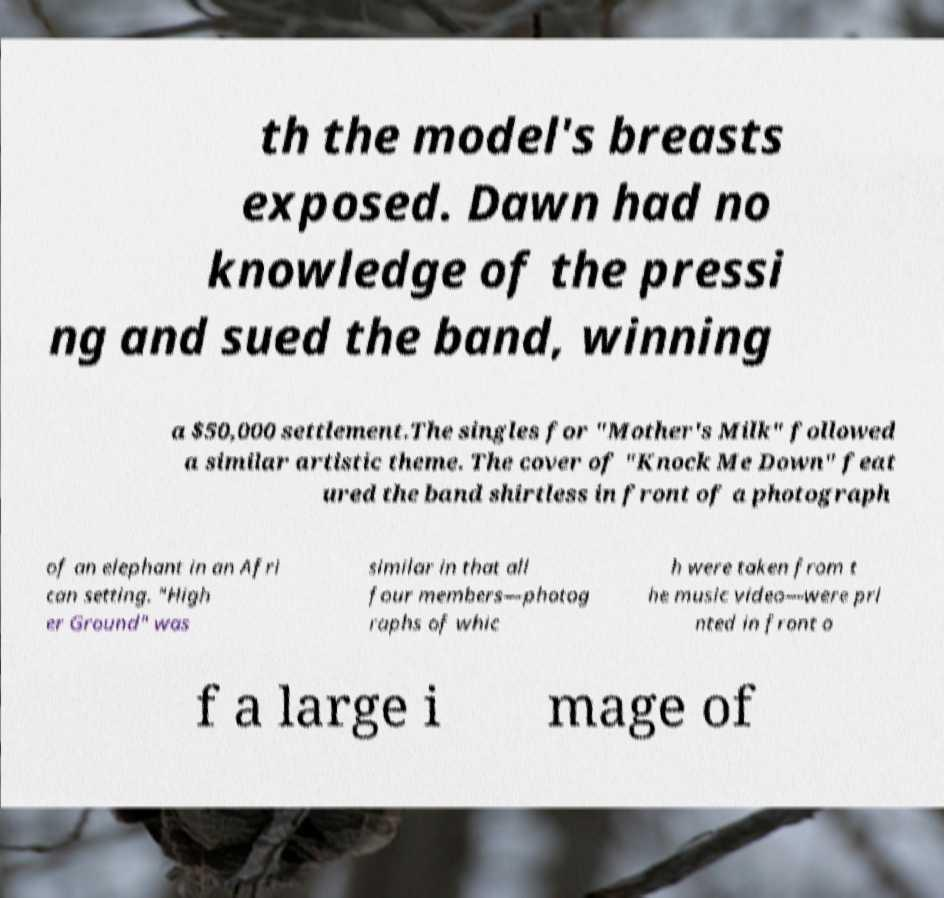I need the written content from this picture converted into text. Can you do that? th the model's breasts exposed. Dawn had no knowledge of the pressi ng and sued the band, winning a $50,000 settlement.The singles for "Mother's Milk" followed a similar artistic theme. The cover of "Knock Me Down" feat ured the band shirtless in front of a photograph of an elephant in an Afri can setting. "High er Ground" was similar in that all four members—photog raphs of whic h were taken from t he music video—were pri nted in front o f a large i mage of 